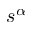<formula> <loc_0><loc_0><loc_500><loc_500>s ^ { \alpha }</formula> 